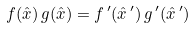<formula> <loc_0><loc_0><loc_500><loc_500>f ( { \hat { x } } ) \, g ( { \hat { x } } ) = f \, ^ { \prime } ( { \hat { x } } \, ^ { \prime } ) \, g \, ^ { \prime } ( { \hat { x } } \, ^ { \prime } )</formula> 